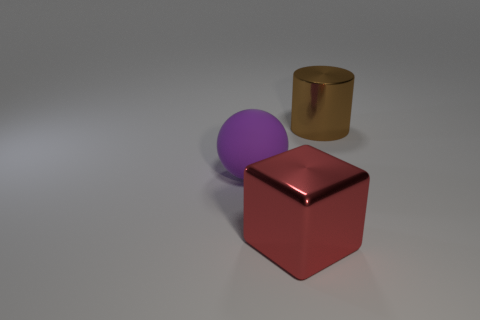There is a large rubber object; what number of big cylinders are right of it?
Ensure brevity in your answer.  1. Is the shape of the brown thing the same as the red metallic object?
Your answer should be very brief. No. What number of big shiny objects are behind the red metal thing and in front of the large brown metallic thing?
Your answer should be compact. 0. How many objects are either small blue spheres or shiny objects that are behind the large metallic block?
Ensure brevity in your answer.  1. Are there more large spheres than big objects?
Keep it short and to the point. No. What is the shape of the metallic object that is in front of the purple matte thing?
Ensure brevity in your answer.  Cube. How many other large things are the same shape as the purple matte object?
Give a very brief answer. 0. There is a metallic thing in front of the large thing that is to the left of the big red metal object; what size is it?
Provide a succinct answer. Large. What number of brown objects are large cubes or spheres?
Keep it short and to the point. 0. Are there fewer big blocks in front of the big cube than large purple spheres that are to the right of the big rubber thing?
Your response must be concise. No. 